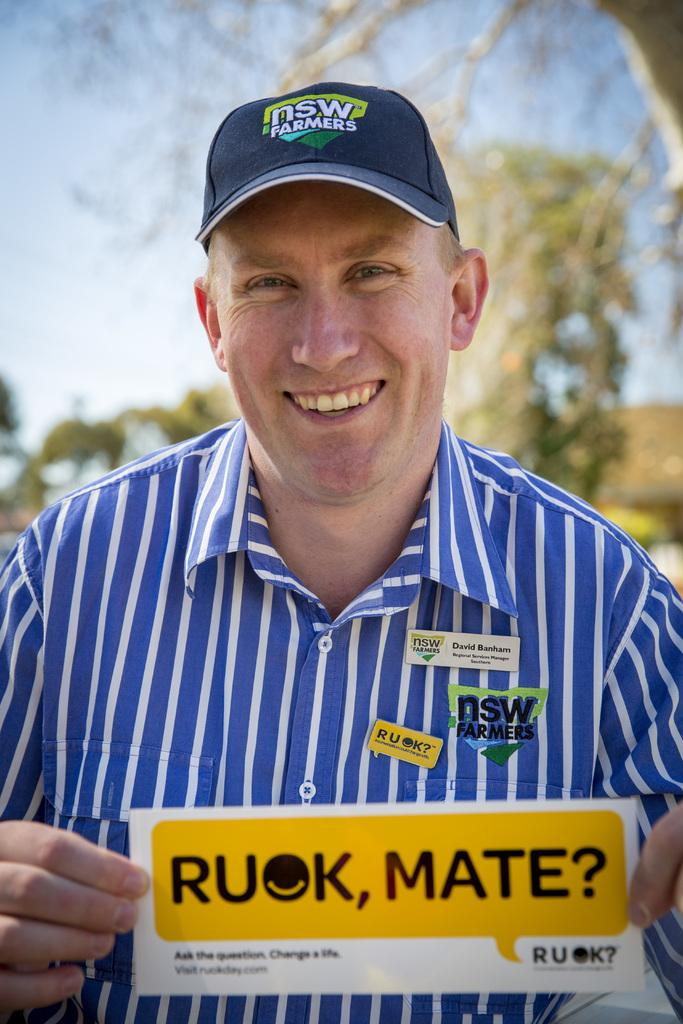Provide a one-sentence caption for the provided image. A blue hat that has the words nsw farmers on it. 